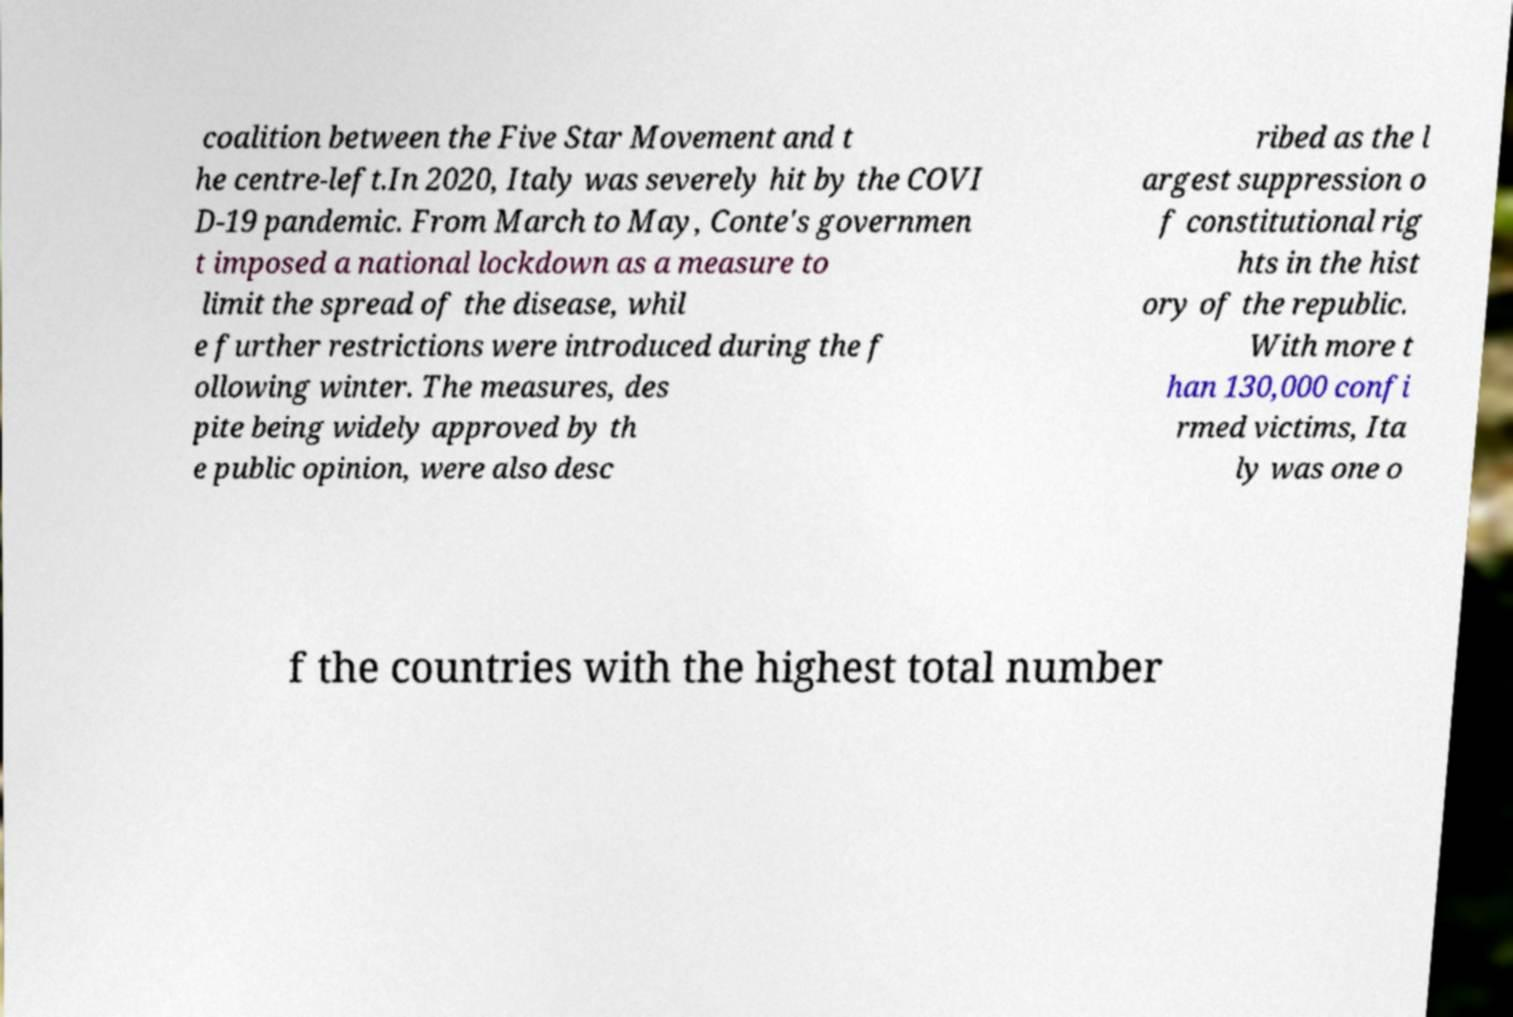Could you assist in decoding the text presented in this image and type it out clearly? coalition between the Five Star Movement and t he centre-left.In 2020, Italy was severely hit by the COVI D-19 pandemic. From March to May, Conte's governmen t imposed a national lockdown as a measure to limit the spread of the disease, whil e further restrictions were introduced during the f ollowing winter. The measures, des pite being widely approved by th e public opinion, were also desc ribed as the l argest suppression o f constitutional rig hts in the hist ory of the republic. With more t han 130,000 confi rmed victims, Ita ly was one o f the countries with the highest total number 